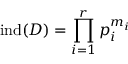Convert formula to latex. <formula><loc_0><loc_0><loc_500><loc_500>i n d ( D ) = \prod _ { i = 1 } ^ { r } p _ { i } ^ { m _ { i } }</formula> 